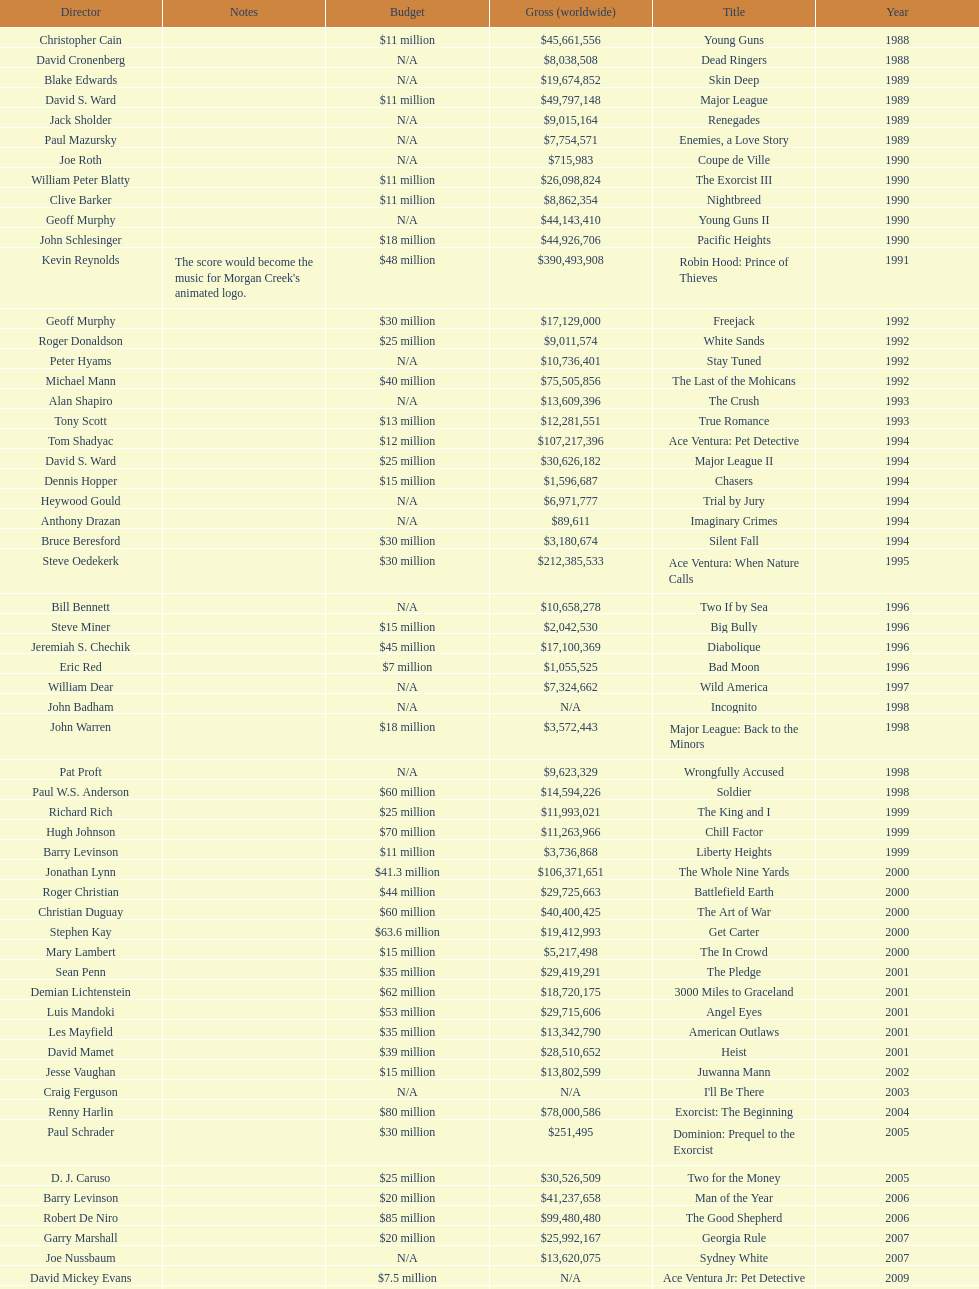How many films did morgan creek make in 2006? 2. 